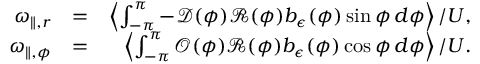Convert formula to latex. <formula><loc_0><loc_0><loc_500><loc_500>\begin{array} { r l r } { \omega _ { \| , r } } & { = } & { \left \langle \int _ { - \pi } ^ { \pi } - \mathcal { D } ( \phi ) \mathcal { R } ( \phi ) b _ { \epsilon } ( \phi ) \sin \phi \, d \phi \right \rangle / U , } \\ { \omega _ { \| , \phi } } & { = } & { \left \langle \int _ { - \pi } ^ { \pi } \mathcal { O } ( \phi ) \mathcal { R } ( \phi ) b _ { \epsilon } ( \phi ) \cos \phi \, d \phi \right \rangle / U . } \end{array}</formula> 